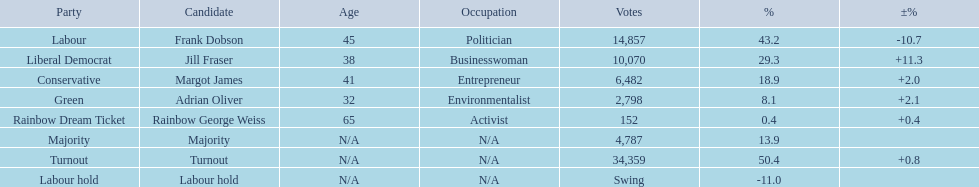How many votes did both the conservative party and the rainbow dream ticket party receive? 6634. 